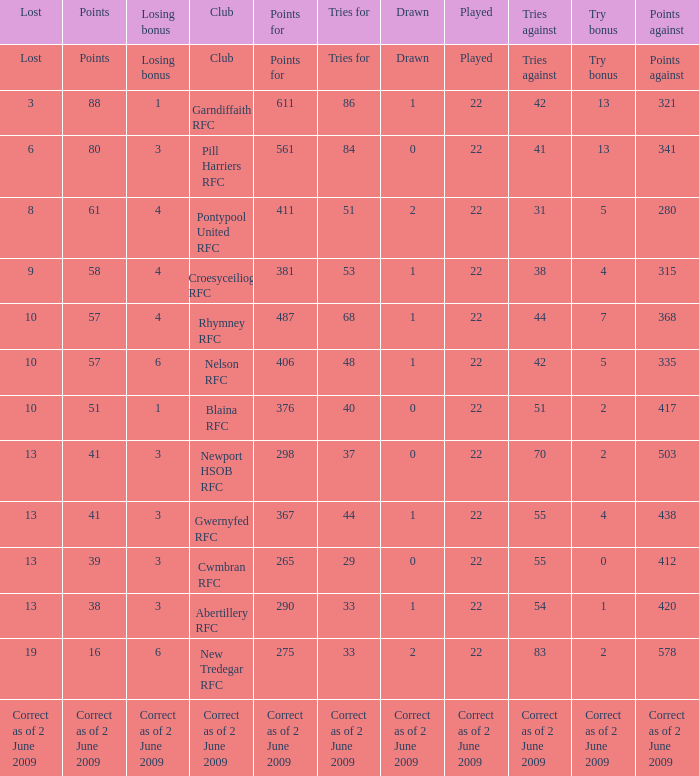How many tries did the club with a try bonus of correct as of 2 June 2009 have? Correct as of 2 June 2009. 